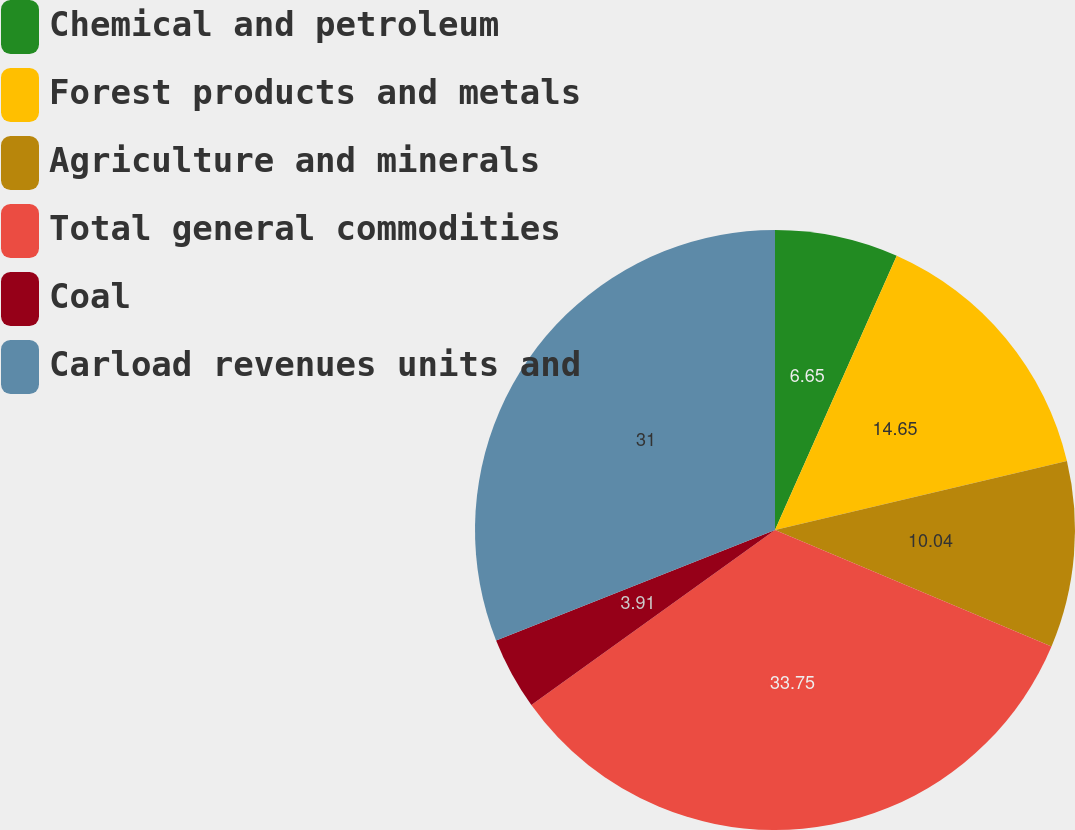<chart> <loc_0><loc_0><loc_500><loc_500><pie_chart><fcel>Chemical and petroleum<fcel>Forest products and metals<fcel>Agriculture and minerals<fcel>Total general commodities<fcel>Coal<fcel>Carload revenues units and<nl><fcel>6.65%<fcel>14.65%<fcel>10.04%<fcel>33.74%<fcel>3.91%<fcel>31.0%<nl></chart> 